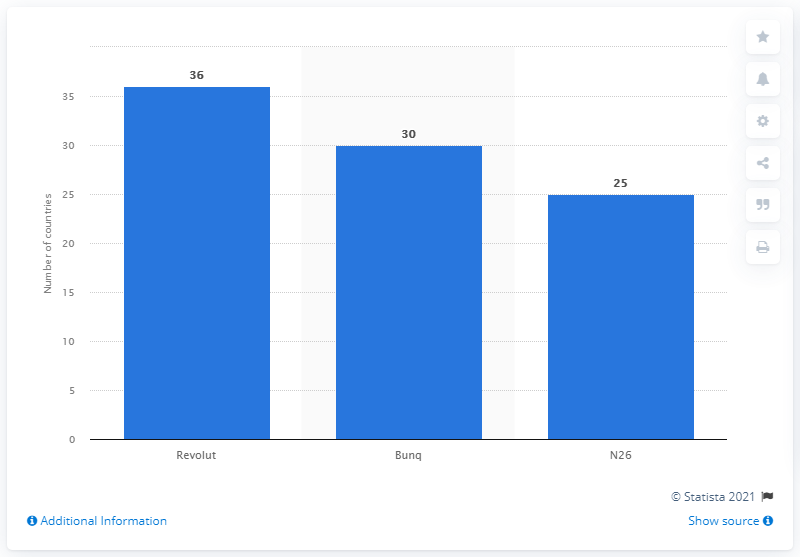List a handful of essential elements in this visual. Revolut is the largest mobile-based app in Europe. 